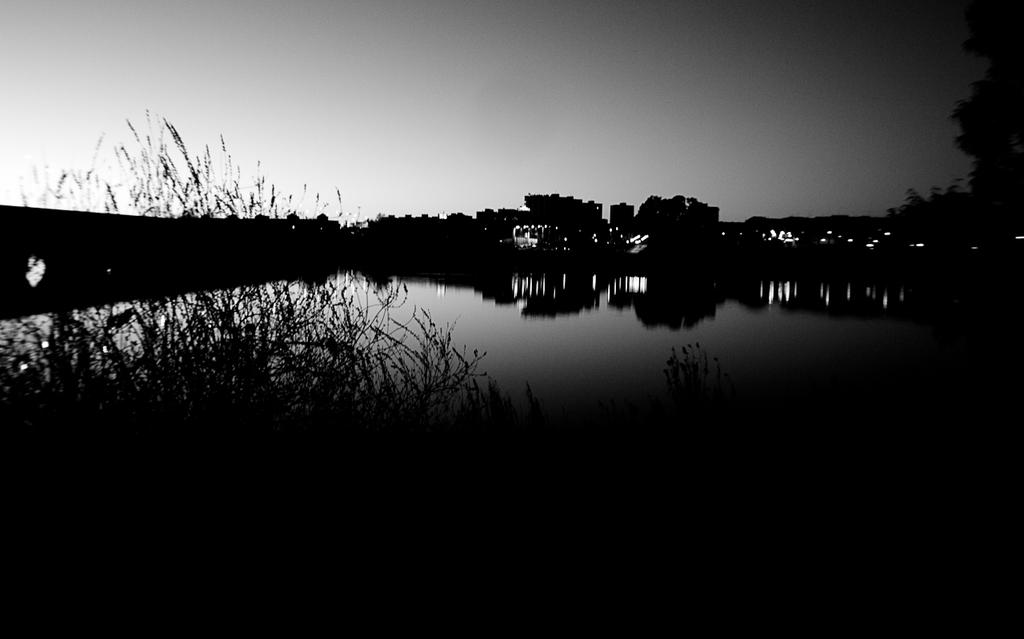What is the overall lighting condition of the image? The image is dark. What type of vegetation can be seen in the image? There are plants and trees in the image. What natural element is visible in the image? There is water visible in the image. What can be seen in the background of the image? The sky is visible in the background of the image. What type of record can be seen playing in the image? There is no record or any indication of music playing in the image. How do the cows feel about the plants in the image? There are no cows present in the image, so their feelings about the plants cannot be determined. 